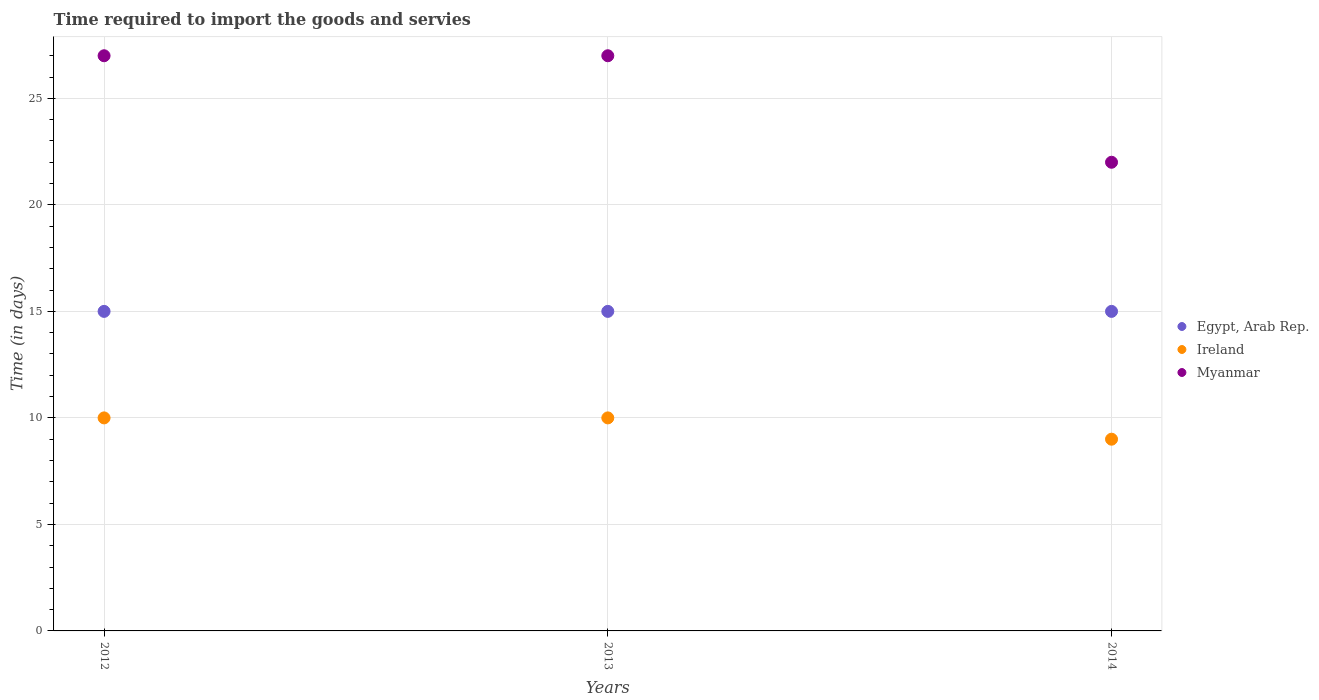Is the number of dotlines equal to the number of legend labels?
Provide a short and direct response. Yes. What is the number of days required to import the goods and services in Ireland in 2013?
Your answer should be very brief. 10. Across all years, what is the maximum number of days required to import the goods and services in Myanmar?
Make the answer very short. 27. Across all years, what is the minimum number of days required to import the goods and services in Ireland?
Provide a short and direct response. 9. What is the total number of days required to import the goods and services in Ireland in the graph?
Provide a short and direct response. 29. What is the difference between the number of days required to import the goods and services in Myanmar in 2012 and that in 2013?
Your answer should be very brief. 0. What is the difference between the number of days required to import the goods and services in Myanmar in 2013 and the number of days required to import the goods and services in Ireland in 2014?
Your answer should be compact. 18. What is the average number of days required to import the goods and services in Ireland per year?
Provide a short and direct response. 9.67. In the year 2014, what is the difference between the number of days required to import the goods and services in Egypt, Arab Rep. and number of days required to import the goods and services in Ireland?
Give a very brief answer. 6. In how many years, is the number of days required to import the goods and services in Egypt, Arab Rep. greater than 15 days?
Offer a very short reply. 0. What is the ratio of the number of days required to import the goods and services in Myanmar in 2012 to that in 2014?
Your answer should be very brief. 1.23. Is the difference between the number of days required to import the goods and services in Egypt, Arab Rep. in 2013 and 2014 greater than the difference between the number of days required to import the goods and services in Ireland in 2013 and 2014?
Keep it short and to the point. No. What is the difference between the highest and the second highest number of days required to import the goods and services in Egypt, Arab Rep.?
Your response must be concise. 0. In how many years, is the number of days required to import the goods and services in Myanmar greater than the average number of days required to import the goods and services in Myanmar taken over all years?
Make the answer very short. 2. Is the sum of the number of days required to import the goods and services in Egypt, Arab Rep. in 2013 and 2014 greater than the maximum number of days required to import the goods and services in Ireland across all years?
Keep it short and to the point. Yes. Is it the case that in every year, the sum of the number of days required to import the goods and services in Myanmar and number of days required to import the goods and services in Egypt, Arab Rep.  is greater than the number of days required to import the goods and services in Ireland?
Provide a short and direct response. Yes. Does the number of days required to import the goods and services in Myanmar monotonically increase over the years?
Provide a succinct answer. No. Is the number of days required to import the goods and services in Ireland strictly greater than the number of days required to import the goods and services in Egypt, Arab Rep. over the years?
Provide a succinct answer. No. Does the graph contain grids?
Provide a succinct answer. Yes. How many legend labels are there?
Keep it short and to the point. 3. What is the title of the graph?
Ensure brevity in your answer.  Time required to import the goods and servies. Does "Angola" appear as one of the legend labels in the graph?
Provide a short and direct response. No. What is the label or title of the Y-axis?
Your response must be concise. Time (in days). What is the Time (in days) in Ireland in 2012?
Make the answer very short. 10. What is the Time (in days) of Myanmar in 2012?
Provide a short and direct response. 27. What is the Time (in days) in Egypt, Arab Rep. in 2013?
Your response must be concise. 15. What is the Time (in days) in Myanmar in 2013?
Your answer should be very brief. 27. Across all years, what is the maximum Time (in days) of Myanmar?
Make the answer very short. 27. Across all years, what is the minimum Time (in days) of Egypt, Arab Rep.?
Offer a terse response. 15. Across all years, what is the minimum Time (in days) in Ireland?
Your answer should be compact. 9. Across all years, what is the minimum Time (in days) of Myanmar?
Offer a terse response. 22. What is the total Time (in days) of Egypt, Arab Rep. in the graph?
Your answer should be very brief. 45. What is the total Time (in days) in Ireland in the graph?
Offer a very short reply. 29. What is the difference between the Time (in days) in Egypt, Arab Rep. in 2012 and that in 2014?
Give a very brief answer. 0. What is the difference between the Time (in days) of Ireland in 2012 and that in 2014?
Your answer should be very brief. 1. What is the difference between the Time (in days) in Myanmar in 2012 and that in 2014?
Your answer should be compact. 5. What is the difference between the Time (in days) of Ireland in 2013 and that in 2014?
Keep it short and to the point. 1. What is the difference between the Time (in days) of Egypt, Arab Rep. in 2012 and the Time (in days) of Ireland in 2013?
Your answer should be compact. 5. What is the difference between the Time (in days) of Ireland in 2012 and the Time (in days) of Myanmar in 2013?
Your response must be concise. -17. What is the difference between the Time (in days) in Egypt, Arab Rep. in 2012 and the Time (in days) in Ireland in 2014?
Ensure brevity in your answer.  6. What is the difference between the Time (in days) of Egypt, Arab Rep. in 2013 and the Time (in days) of Myanmar in 2014?
Give a very brief answer. -7. What is the average Time (in days) of Egypt, Arab Rep. per year?
Provide a succinct answer. 15. What is the average Time (in days) in Ireland per year?
Your answer should be compact. 9.67. What is the average Time (in days) in Myanmar per year?
Offer a terse response. 25.33. In the year 2012, what is the difference between the Time (in days) of Egypt, Arab Rep. and Time (in days) of Ireland?
Your answer should be very brief. 5. In the year 2014, what is the difference between the Time (in days) of Egypt, Arab Rep. and Time (in days) of Ireland?
Keep it short and to the point. 6. In the year 2014, what is the difference between the Time (in days) of Egypt, Arab Rep. and Time (in days) of Myanmar?
Your answer should be compact. -7. What is the ratio of the Time (in days) of Myanmar in 2012 to that in 2013?
Offer a terse response. 1. What is the ratio of the Time (in days) of Egypt, Arab Rep. in 2012 to that in 2014?
Give a very brief answer. 1. What is the ratio of the Time (in days) in Myanmar in 2012 to that in 2014?
Provide a succinct answer. 1.23. What is the ratio of the Time (in days) of Ireland in 2013 to that in 2014?
Your response must be concise. 1.11. What is the ratio of the Time (in days) in Myanmar in 2013 to that in 2014?
Provide a short and direct response. 1.23. What is the difference between the highest and the second highest Time (in days) of Egypt, Arab Rep.?
Offer a terse response. 0. What is the difference between the highest and the second highest Time (in days) in Myanmar?
Give a very brief answer. 0. What is the difference between the highest and the lowest Time (in days) of Egypt, Arab Rep.?
Keep it short and to the point. 0. What is the difference between the highest and the lowest Time (in days) of Ireland?
Offer a very short reply. 1. 